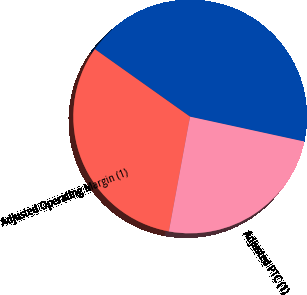<chart> <loc_0><loc_0><loc_500><loc_500><pie_chart><fcel>Operating Margin<fcel>Adjusted Operating Margin (1)<fcel>Adjusted PTC (1)<nl><fcel>43.59%<fcel>31.92%<fcel>24.49%<nl></chart> 